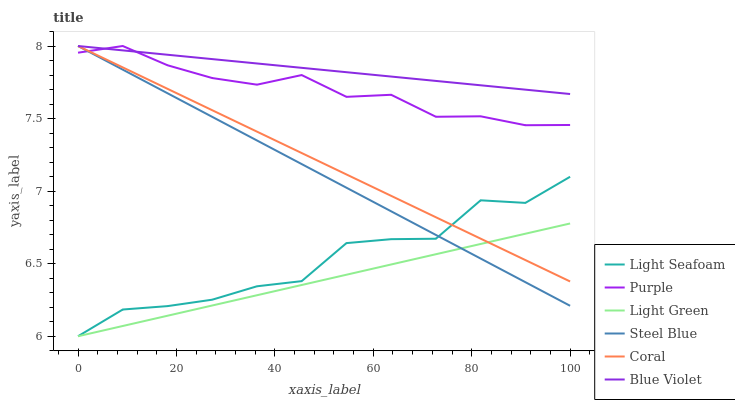Does Light Green have the minimum area under the curve?
Answer yes or no. Yes. Does Blue Violet have the maximum area under the curve?
Answer yes or no. Yes. Does Coral have the minimum area under the curve?
Answer yes or no. No. Does Coral have the maximum area under the curve?
Answer yes or no. No. Is Light Green the smoothest?
Answer yes or no. Yes. Is Light Seafoam the roughest?
Answer yes or no. Yes. Is Coral the smoothest?
Answer yes or no. No. Is Coral the roughest?
Answer yes or no. No. Does Coral have the lowest value?
Answer yes or no. No. Does Light Green have the highest value?
Answer yes or no. No. Is Light Seafoam less than Purple?
Answer yes or no. Yes. Is Blue Violet greater than Light Green?
Answer yes or no. Yes. Does Light Seafoam intersect Purple?
Answer yes or no. No. 